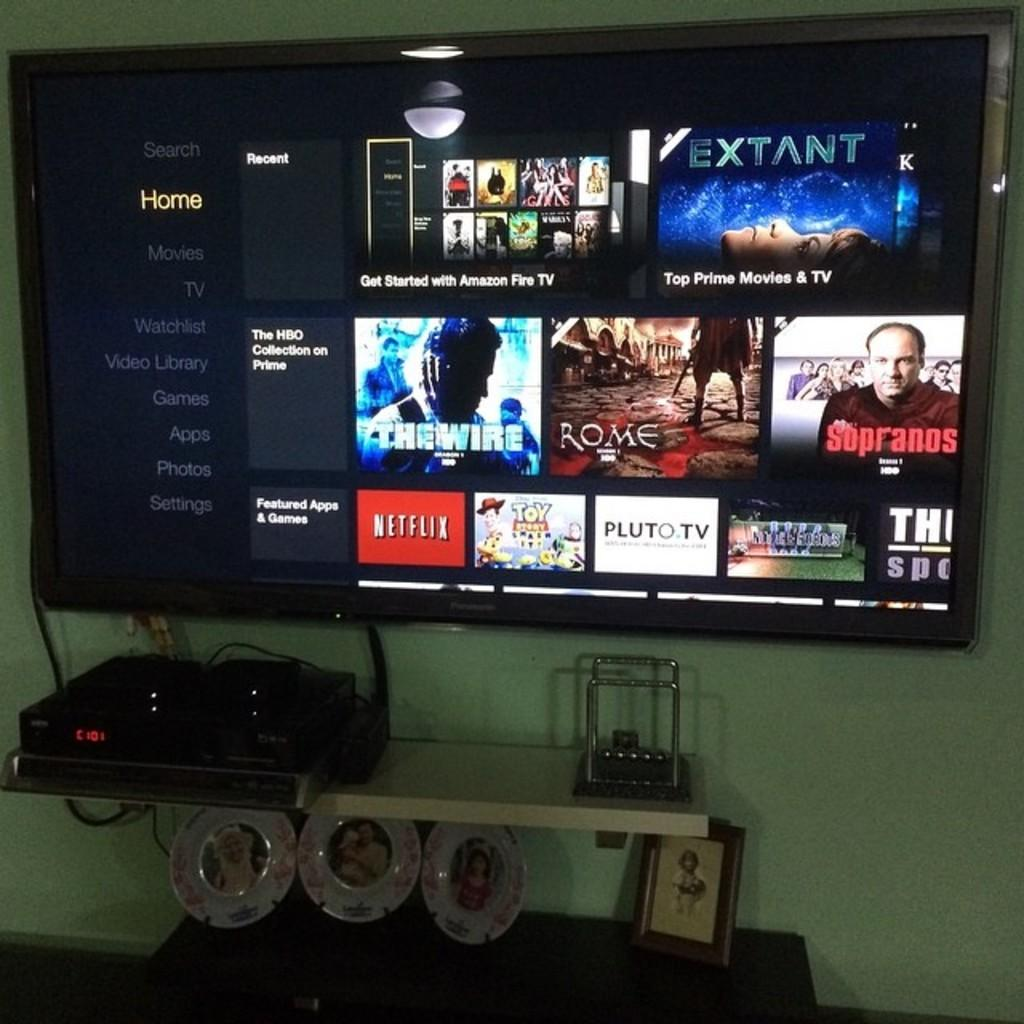<image>
Relay a brief, clear account of the picture shown. a flat screen tv displaying shows from netflix and the sopranos 